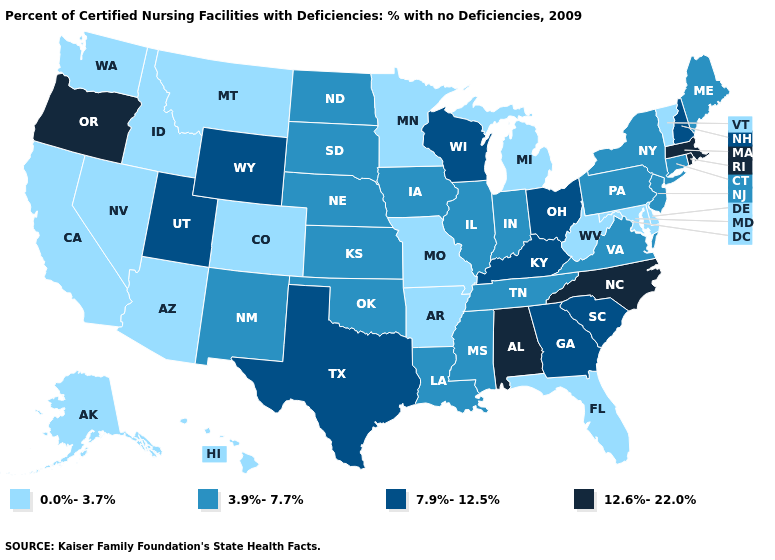What is the highest value in the Northeast ?
Be succinct. 12.6%-22.0%. Does Iowa have the lowest value in the USA?
Be succinct. No. Name the states that have a value in the range 7.9%-12.5%?
Give a very brief answer. Georgia, Kentucky, New Hampshire, Ohio, South Carolina, Texas, Utah, Wisconsin, Wyoming. What is the value of Alabama?
Answer briefly. 12.6%-22.0%. Name the states that have a value in the range 3.9%-7.7%?
Be succinct. Connecticut, Illinois, Indiana, Iowa, Kansas, Louisiana, Maine, Mississippi, Nebraska, New Jersey, New Mexico, New York, North Dakota, Oklahoma, Pennsylvania, South Dakota, Tennessee, Virginia. What is the highest value in states that border Ohio?
Concise answer only. 7.9%-12.5%. What is the highest value in the South ?
Give a very brief answer. 12.6%-22.0%. Name the states that have a value in the range 3.9%-7.7%?
Short answer required. Connecticut, Illinois, Indiana, Iowa, Kansas, Louisiana, Maine, Mississippi, Nebraska, New Jersey, New Mexico, New York, North Dakota, Oklahoma, Pennsylvania, South Dakota, Tennessee, Virginia. Which states have the lowest value in the USA?
Concise answer only. Alaska, Arizona, Arkansas, California, Colorado, Delaware, Florida, Hawaii, Idaho, Maryland, Michigan, Minnesota, Missouri, Montana, Nevada, Vermont, Washington, West Virginia. What is the highest value in the MidWest ?
Write a very short answer. 7.9%-12.5%. Which states hav the highest value in the South?
Keep it brief. Alabama, North Carolina. Is the legend a continuous bar?
Concise answer only. No. What is the value of Rhode Island?
Concise answer only. 12.6%-22.0%. What is the value of North Carolina?
Write a very short answer. 12.6%-22.0%. Name the states that have a value in the range 0.0%-3.7%?
Be succinct. Alaska, Arizona, Arkansas, California, Colorado, Delaware, Florida, Hawaii, Idaho, Maryland, Michigan, Minnesota, Missouri, Montana, Nevada, Vermont, Washington, West Virginia. 